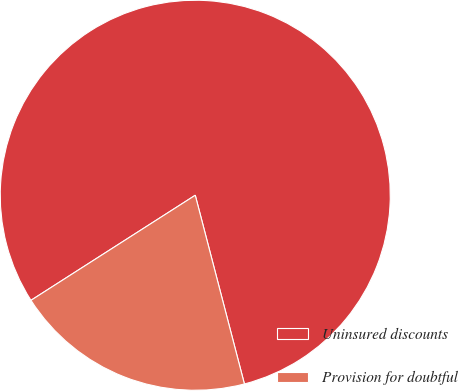Convert chart. <chart><loc_0><loc_0><loc_500><loc_500><pie_chart><fcel>Uninsured discounts<fcel>Provision for doubtful<nl><fcel>80.0%<fcel>20.0%<nl></chart> 